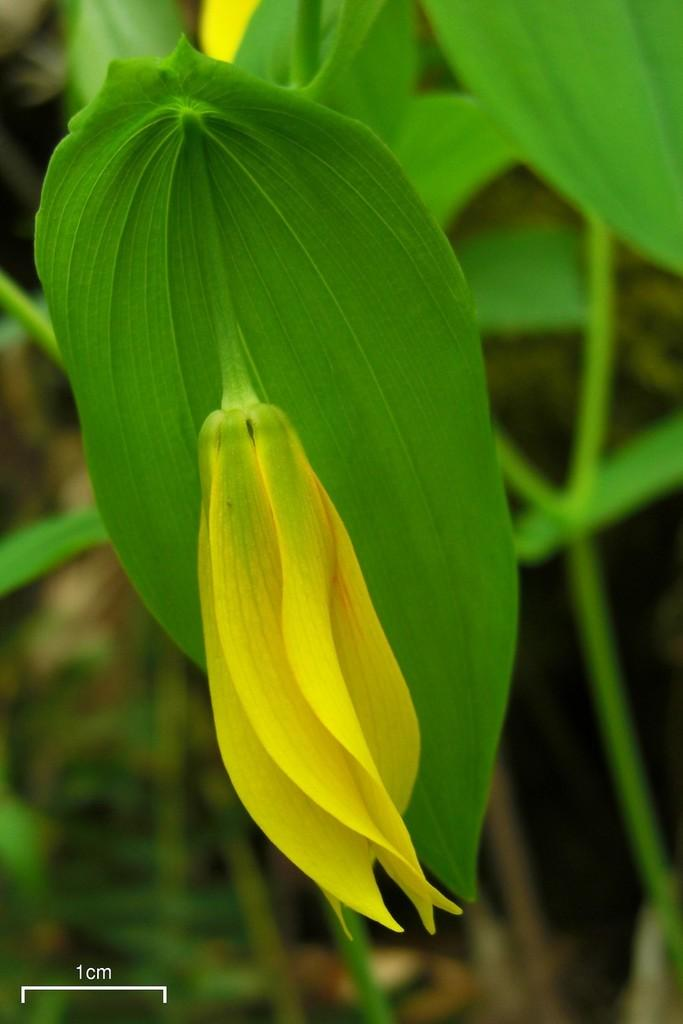What is present in the image? There is a plant in the image. What can be observed about the plant's flower? The plant has a flower in yellow color. What is the color of the plant's leaves? The leaves of the plant are green. How many holes can be seen in the plant's leaves? There are no holes visible in the plant's leaves in the image. What type of feast is being prepared using the plant in the image? There is no indication of a feast or any preparation involving the plant in the image. 